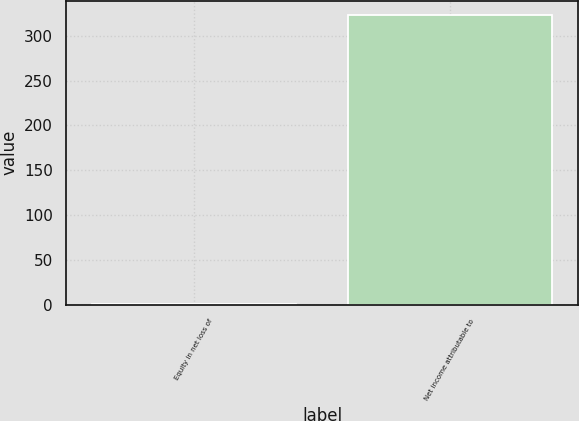Convert chart. <chart><loc_0><loc_0><loc_500><loc_500><bar_chart><fcel>Equity in net loss of<fcel>Net income attributable to<nl><fcel>0.4<fcel>322.9<nl></chart> 